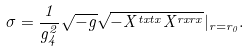Convert formula to latex. <formula><loc_0><loc_0><loc_500><loc_500>\sigma = \frac { 1 } { g ^ { 2 } _ { 4 } } \sqrt { - g } \sqrt { - X ^ { t x t x } X ^ { r x r x } } | _ { r = r _ { 0 } } .</formula> 